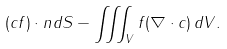<formula> <loc_0><loc_0><loc_500><loc_500>( c f ) \cdot n d S - \iiint _ { V } f ( \nabla \cdot c ) \, d V .</formula> 